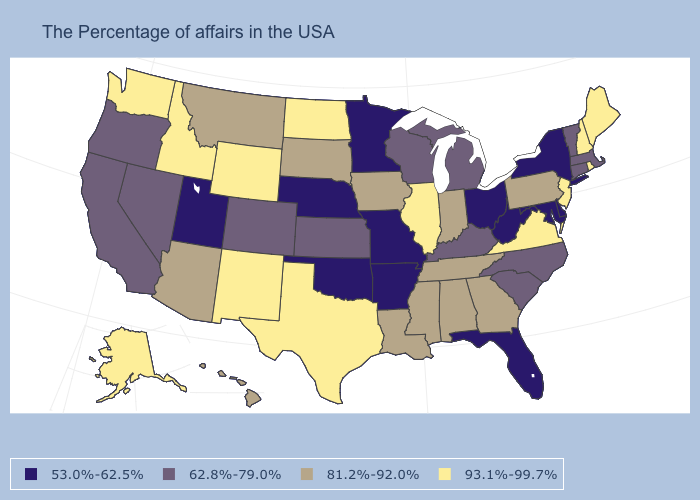Name the states that have a value in the range 81.2%-92.0%?
Keep it brief. Pennsylvania, Georgia, Indiana, Alabama, Tennessee, Mississippi, Louisiana, Iowa, South Dakota, Montana, Arizona, Hawaii. What is the value of Massachusetts?
Answer briefly. 62.8%-79.0%. Does New Jersey have the highest value in the USA?
Keep it brief. Yes. Name the states that have a value in the range 93.1%-99.7%?
Give a very brief answer. Maine, Rhode Island, New Hampshire, New Jersey, Virginia, Illinois, Texas, North Dakota, Wyoming, New Mexico, Idaho, Washington, Alaska. What is the value of Tennessee?
Short answer required. 81.2%-92.0%. How many symbols are there in the legend?
Answer briefly. 4. What is the lowest value in the South?
Concise answer only. 53.0%-62.5%. What is the lowest value in states that border Vermont?
Keep it brief. 53.0%-62.5%. What is the value of New Mexico?
Answer briefly. 93.1%-99.7%. Does Maryland have the same value as New York?
Concise answer only. Yes. Name the states that have a value in the range 62.8%-79.0%?
Keep it brief. Massachusetts, Vermont, Connecticut, North Carolina, South Carolina, Michigan, Kentucky, Wisconsin, Kansas, Colorado, Nevada, California, Oregon. Which states hav the highest value in the Northeast?
Keep it brief. Maine, Rhode Island, New Hampshire, New Jersey. Name the states that have a value in the range 53.0%-62.5%?
Keep it brief. New York, Delaware, Maryland, West Virginia, Ohio, Florida, Missouri, Arkansas, Minnesota, Nebraska, Oklahoma, Utah. Name the states that have a value in the range 53.0%-62.5%?
Write a very short answer. New York, Delaware, Maryland, West Virginia, Ohio, Florida, Missouri, Arkansas, Minnesota, Nebraska, Oklahoma, Utah. Which states hav the highest value in the South?
Short answer required. Virginia, Texas. 